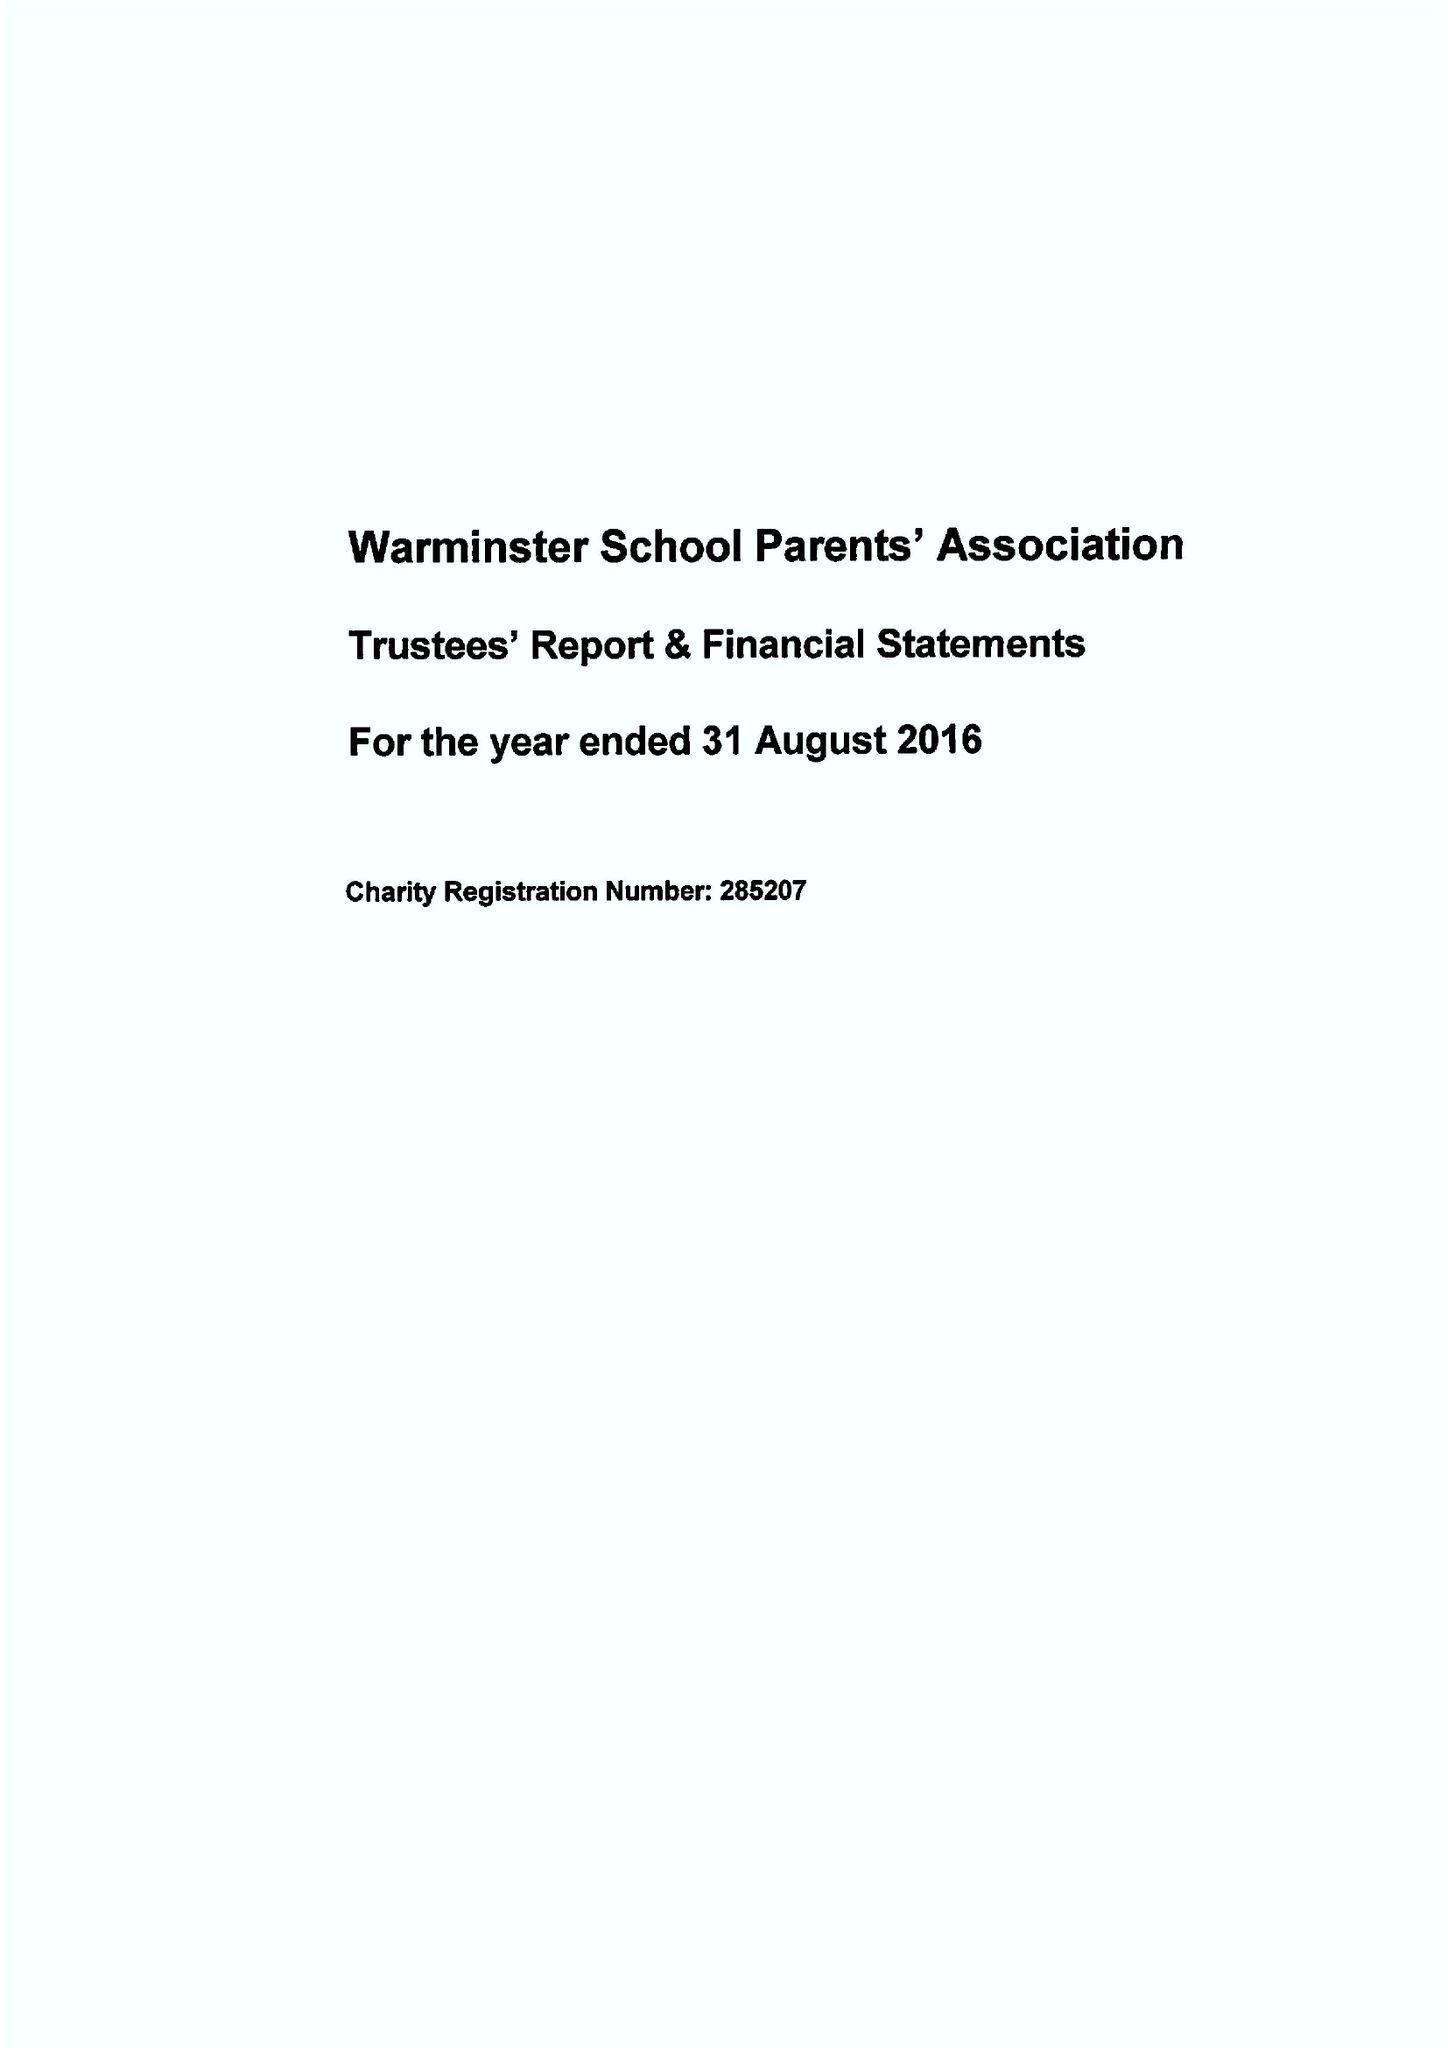What is the value for the address__postcode?
Answer the question using a single word or phrase. BA12 8PJ 